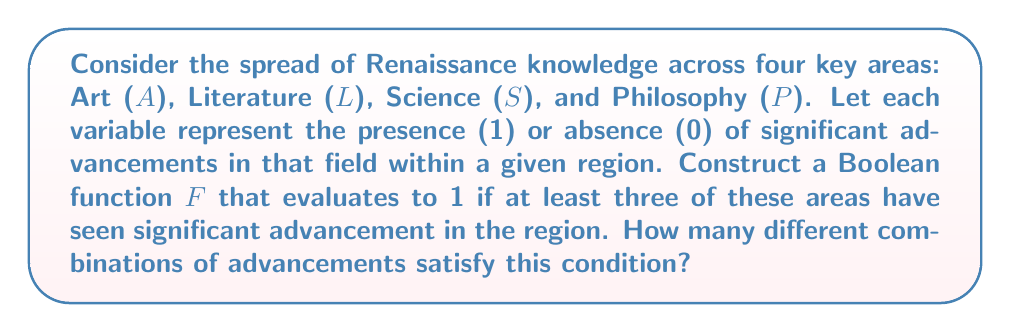Teach me how to tackle this problem. To solve this problem, we'll follow these steps:

1) First, let's define our Boolean function F:

   $$F(A, L, S, P) = 1$$ if at least three areas have advanced (1), and 0 otherwise.

2) We need to count the number of input combinations where F = 1. This occurs when:
   - All four areas have advanced
   - Any three areas have advanced

3) Let's count these combinations:

   a) All four areas advanced: There's only one combination (1111)
   
   b) Exactly three areas advanced: We need to choose 3 out of 4 areas. This can be done in $\binom{4}{3} = 4$ ways:
      - ALS (1110)
      - ALP (1101)
      - ASP (1011)
      - LSP (0111)

4) In total, we have 1 + 4 = 5 combinations where F = 1.

5) We can express F using the sum-of-products (SOP) form:

   $$F = ALSP + ALS\overline{P} + AL\overline{S}P + A\overline{L}SP + \overline{A}LSP$$

   Where each term represents one of the satisfying combinations.

6) Alternatively, we could use the concept of majority function:

   $$F = MAJ(A, L, S, P)$$

   Where MAJ is the 3-out-of-4 majority function.
Answer: 5 combinations 